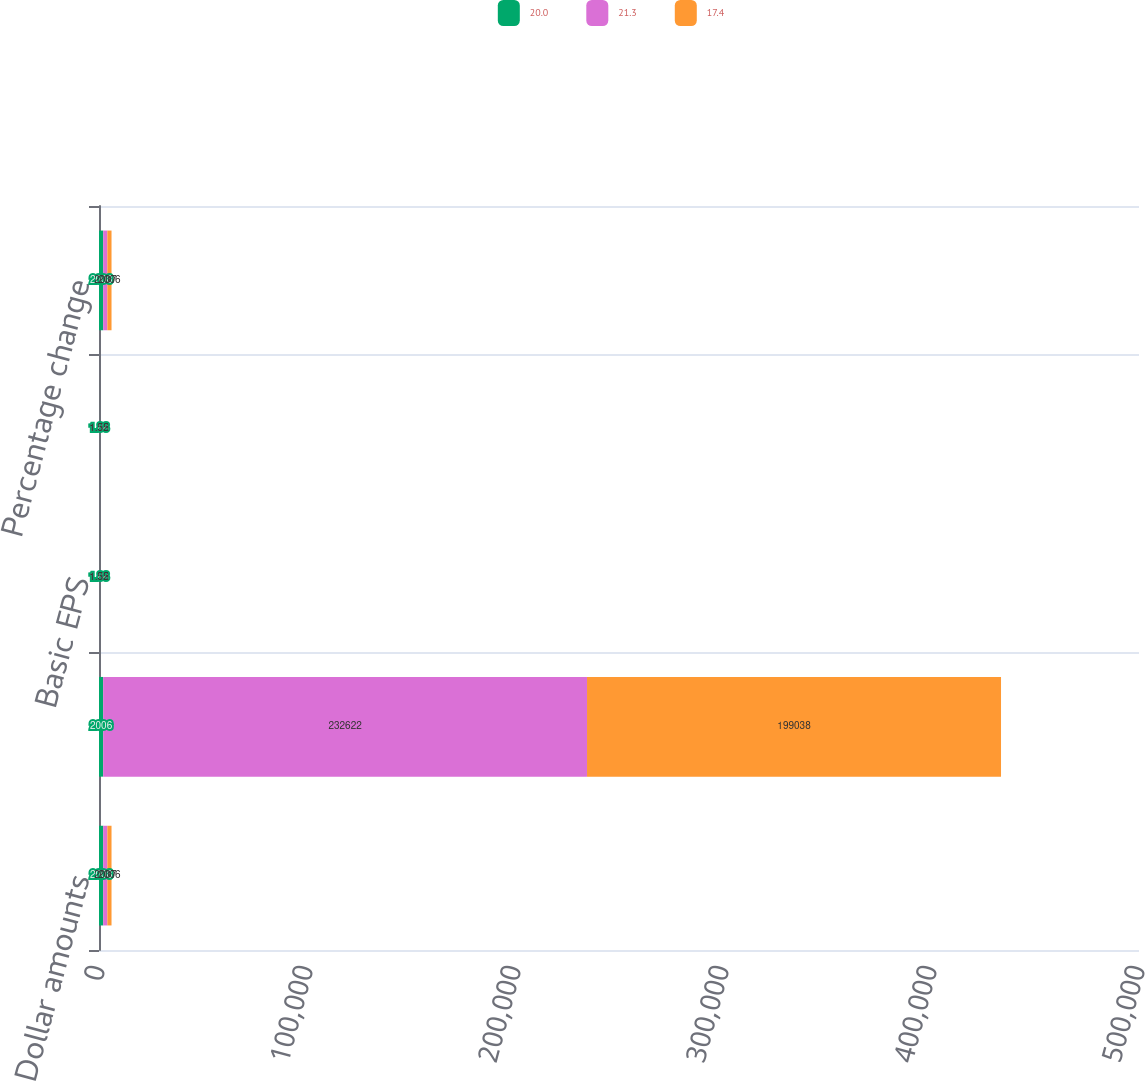Convert chart to OTSL. <chart><loc_0><loc_0><loc_500><loc_500><stacked_bar_chart><ecel><fcel>Dollar amounts<fcel>Net earnings<fcel>Basic EPS<fcel>Diluted EPS<fcel>Percentage change<nl><fcel>20<fcel>2008<fcel>2006<fcel>1.88<fcel>1.88<fcel>2008<nl><fcel>21.3<fcel>2007<fcel>232622<fcel>1.55<fcel>1.55<fcel>2007<nl><fcel>17.4<fcel>2006<fcel>199038<fcel>1.32<fcel>1.32<fcel>2006<nl></chart> 